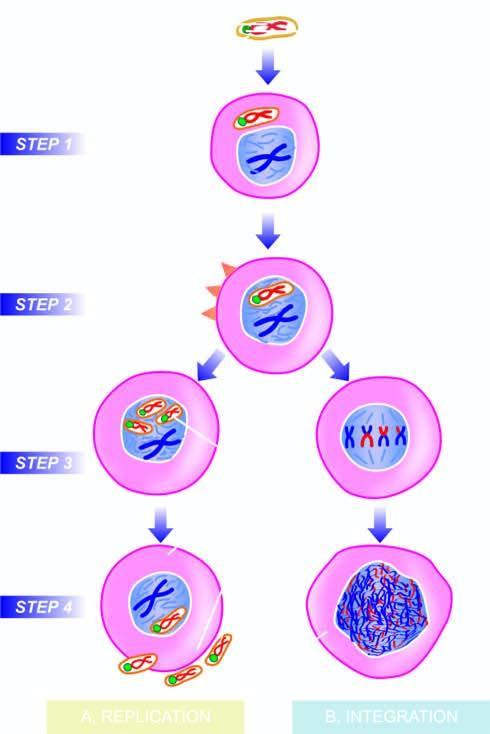s t-antigen expressed immediately after infection?
Answer the question using a single word or phrase. Yes 